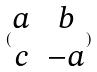Convert formula to latex. <formula><loc_0><loc_0><loc_500><loc_500>( \begin{matrix} a & b \\ c & - a \end{matrix} )</formula> 